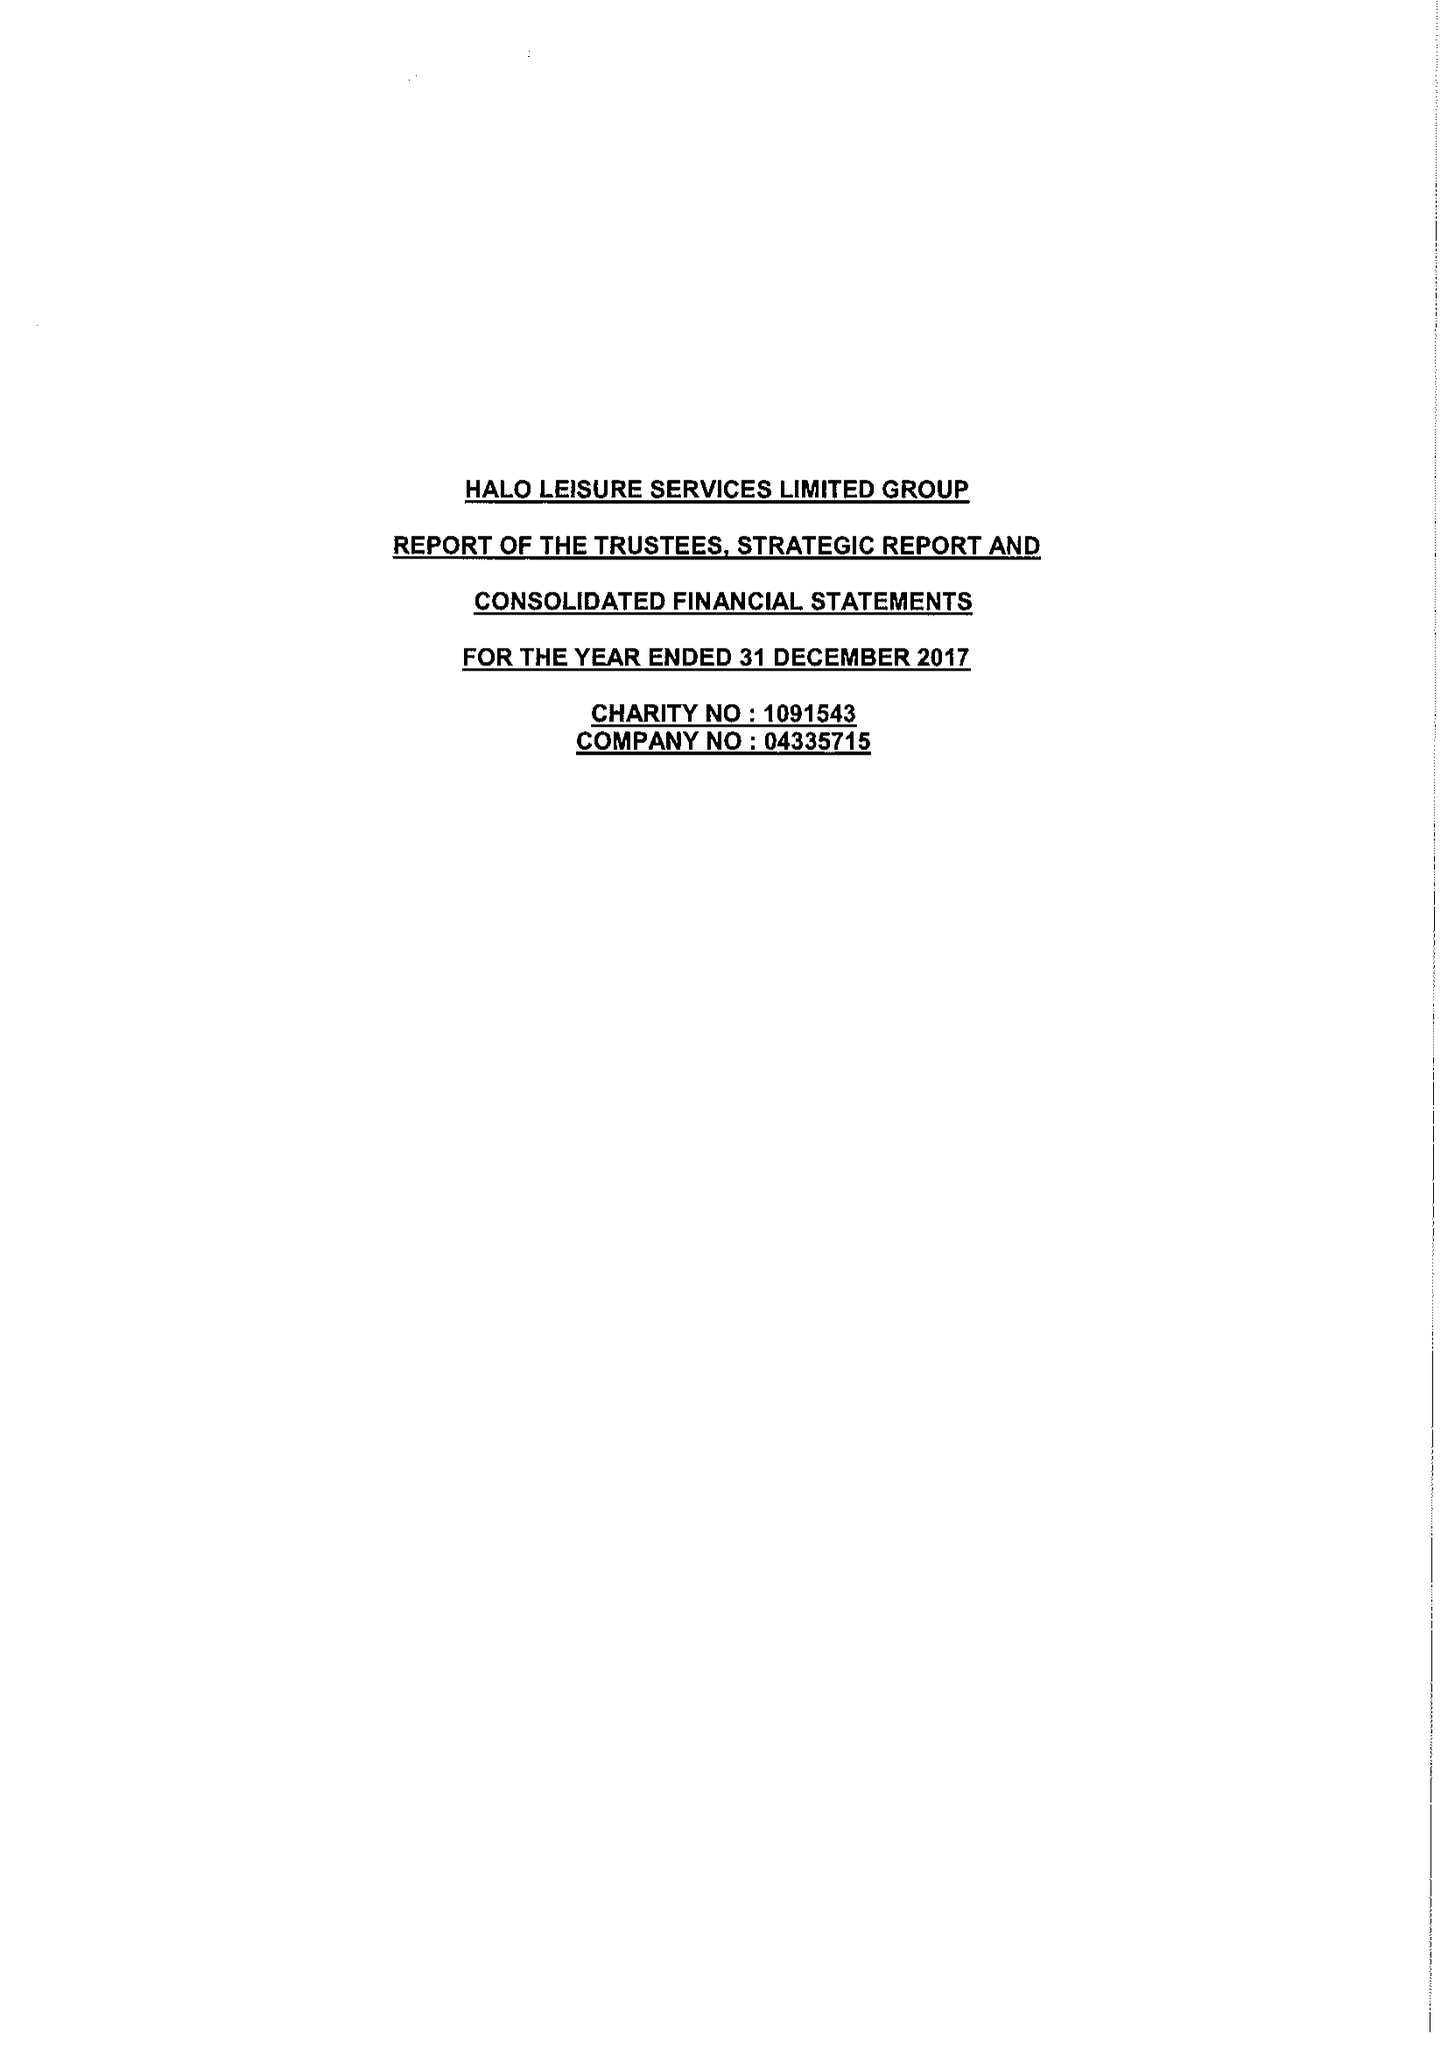What is the value for the report_date?
Answer the question using a single word or phrase. 2017-12-31 